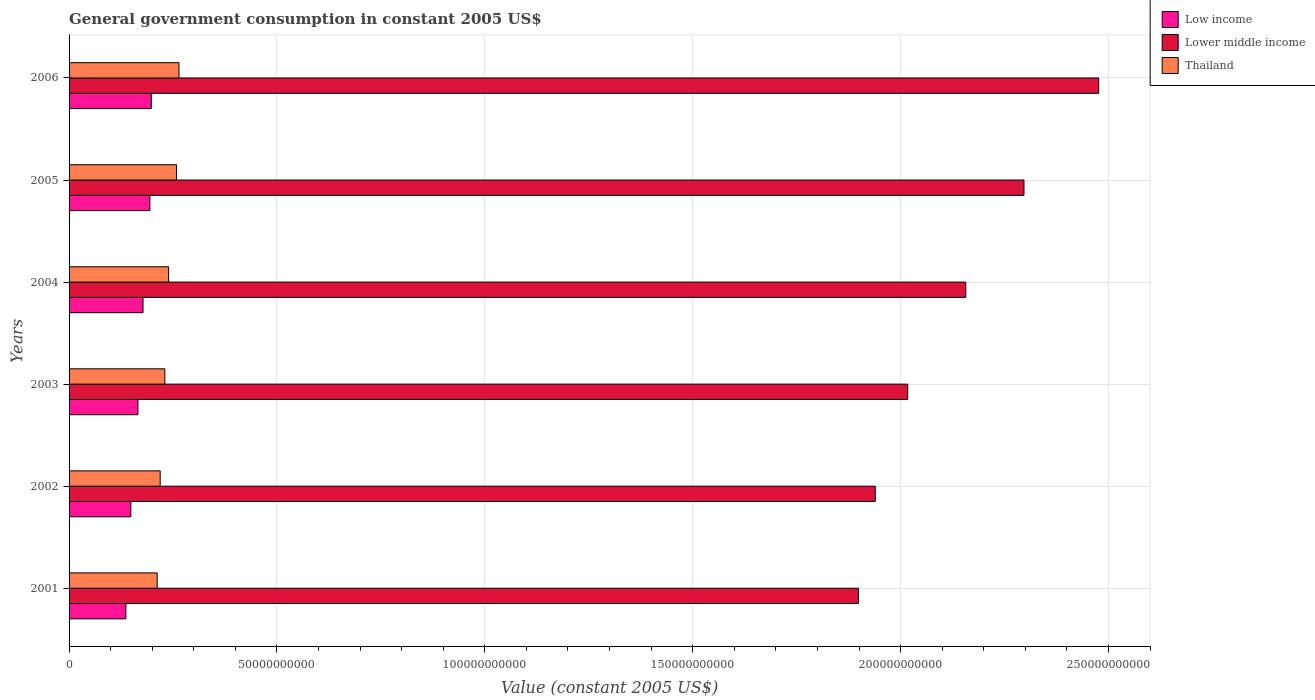How many different coloured bars are there?
Provide a succinct answer. 3. How many bars are there on the 2nd tick from the top?
Provide a succinct answer. 3. In how many cases, is the number of bars for a given year not equal to the number of legend labels?
Make the answer very short. 0. What is the government conusmption in Lower middle income in 2005?
Your answer should be very brief. 2.30e+11. Across all years, what is the maximum government conusmption in Low income?
Give a very brief answer. 1.98e+1. Across all years, what is the minimum government conusmption in Thailand?
Make the answer very short. 2.12e+1. In which year was the government conusmption in Lower middle income maximum?
Provide a short and direct response. 2006. What is the total government conusmption in Lower middle income in the graph?
Give a very brief answer. 1.28e+12. What is the difference between the government conusmption in Thailand in 2001 and that in 2006?
Make the answer very short. -5.24e+09. What is the difference between the government conusmption in Thailand in 2005 and the government conusmption in Low income in 2003?
Your answer should be very brief. 9.29e+09. What is the average government conusmption in Lower middle income per year?
Offer a very short reply. 2.13e+11. In the year 2003, what is the difference between the government conusmption in Lower middle income and government conusmption in Low income?
Ensure brevity in your answer.  1.85e+11. In how many years, is the government conusmption in Thailand greater than 30000000000 US$?
Your response must be concise. 0. What is the ratio of the government conusmption in Lower middle income in 2004 to that in 2005?
Ensure brevity in your answer.  0.94. Is the government conusmption in Thailand in 2001 less than that in 2002?
Your answer should be compact. Yes. What is the difference between the highest and the second highest government conusmption in Lower middle income?
Offer a very short reply. 1.80e+1. What is the difference between the highest and the lowest government conusmption in Lower middle income?
Provide a succinct answer. 5.78e+1. What does the 2nd bar from the bottom in 2003 represents?
Offer a very short reply. Lower middle income. Is it the case that in every year, the sum of the government conusmption in Lower middle income and government conusmption in Low income is greater than the government conusmption in Thailand?
Your answer should be very brief. Yes. How many bars are there?
Keep it short and to the point. 18. Are all the bars in the graph horizontal?
Ensure brevity in your answer.  Yes. How many years are there in the graph?
Your response must be concise. 6. Are the values on the major ticks of X-axis written in scientific E-notation?
Offer a terse response. No. Does the graph contain any zero values?
Your answer should be compact. No. Does the graph contain grids?
Make the answer very short. Yes. Where does the legend appear in the graph?
Provide a short and direct response. Top right. How many legend labels are there?
Keep it short and to the point. 3. What is the title of the graph?
Offer a very short reply. General government consumption in constant 2005 US$. What is the label or title of the X-axis?
Provide a succinct answer. Value (constant 2005 US$). What is the Value (constant 2005 US$) of Low income in 2001?
Your answer should be compact. 1.37e+1. What is the Value (constant 2005 US$) in Lower middle income in 2001?
Give a very brief answer. 1.90e+11. What is the Value (constant 2005 US$) in Thailand in 2001?
Your answer should be compact. 2.12e+1. What is the Value (constant 2005 US$) in Low income in 2002?
Provide a succinct answer. 1.49e+1. What is the Value (constant 2005 US$) of Lower middle income in 2002?
Your answer should be compact. 1.94e+11. What is the Value (constant 2005 US$) in Thailand in 2002?
Offer a terse response. 2.19e+1. What is the Value (constant 2005 US$) in Low income in 2003?
Ensure brevity in your answer.  1.66e+1. What is the Value (constant 2005 US$) of Lower middle income in 2003?
Provide a succinct answer. 2.02e+11. What is the Value (constant 2005 US$) of Thailand in 2003?
Keep it short and to the point. 2.30e+1. What is the Value (constant 2005 US$) in Low income in 2004?
Offer a terse response. 1.78e+1. What is the Value (constant 2005 US$) of Lower middle income in 2004?
Make the answer very short. 2.16e+11. What is the Value (constant 2005 US$) in Thailand in 2004?
Provide a short and direct response. 2.39e+1. What is the Value (constant 2005 US$) of Low income in 2005?
Your answer should be compact. 1.94e+1. What is the Value (constant 2005 US$) in Lower middle income in 2005?
Make the answer very short. 2.30e+11. What is the Value (constant 2005 US$) of Thailand in 2005?
Provide a short and direct response. 2.58e+1. What is the Value (constant 2005 US$) of Low income in 2006?
Your answer should be compact. 1.98e+1. What is the Value (constant 2005 US$) of Lower middle income in 2006?
Provide a succinct answer. 2.48e+11. What is the Value (constant 2005 US$) in Thailand in 2006?
Your response must be concise. 2.64e+1. Across all years, what is the maximum Value (constant 2005 US$) of Low income?
Provide a short and direct response. 1.98e+1. Across all years, what is the maximum Value (constant 2005 US$) in Lower middle income?
Give a very brief answer. 2.48e+11. Across all years, what is the maximum Value (constant 2005 US$) of Thailand?
Provide a succinct answer. 2.64e+1. Across all years, what is the minimum Value (constant 2005 US$) of Low income?
Offer a very short reply. 1.37e+1. Across all years, what is the minimum Value (constant 2005 US$) in Lower middle income?
Provide a succinct answer. 1.90e+11. Across all years, what is the minimum Value (constant 2005 US$) in Thailand?
Give a very brief answer. 2.12e+1. What is the total Value (constant 2005 US$) of Low income in the graph?
Your answer should be very brief. 1.02e+11. What is the total Value (constant 2005 US$) of Lower middle income in the graph?
Your answer should be compact. 1.28e+12. What is the total Value (constant 2005 US$) of Thailand in the graph?
Give a very brief answer. 1.42e+11. What is the difference between the Value (constant 2005 US$) of Low income in 2001 and that in 2002?
Offer a very short reply. -1.19e+09. What is the difference between the Value (constant 2005 US$) in Lower middle income in 2001 and that in 2002?
Your response must be concise. -4.05e+09. What is the difference between the Value (constant 2005 US$) of Thailand in 2001 and that in 2002?
Your response must be concise. -7.23e+08. What is the difference between the Value (constant 2005 US$) of Low income in 2001 and that in 2003?
Give a very brief answer. -2.90e+09. What is the difference between the Value (constant 2005 US$) of Lower middle income in 2001 and that in 2003?
Your answer should be compact. -1.19e+1. What is the difference between the Value (constant 2005 US$) in Thailand in 2001 and that in 2003?
Your answer should be compact. -1.85e+09. What is the difference between the Value (constant 2005 US$) in Low income in 2001 and that in 2004?
Provide a short and direct response. -4.13e+09. What is the difference between the Value (constant 2005 US$) in Lower middle income in 2001 and that in 2004?
Provide a succinct answer. -2.58e+1. What is the difference between the Value (constant 2005 US$) of Thailand in 2001 and that in 2004?
Keep it short and to the point. -2.74e+09. What is the difference between the Value (constant 2005 US$) in Low income in 2001 and that in 2005?
Give a very brief answer. -5.77e+09. What is the difference between the Value (constant 2005 US$) of Lower middle income in 2001 and that in 2005?
Ensure brevity in your answer.  -3.98e+1. What is the difference between the Value (constant 2005 US$) in Thailand in 2001 and that in 2005?
Give a very brief answer. -4.66e+09. What is the difference between the Value (constant 2005 US$) of Low income in 2001 and that in 2006?
Your answer should be compact. -6.11e+09. What is the difference between the Value (constant 2005 US$) in Lower middle income in 2001 and that in 2006?
Offer a very short reply. -5.78e+1. What is the difference between the Value (constant 2005 US$) in Thailand in 2001 and that in 2006?
Provide a short and direct response. -5.24e+09. What is the difference between the Value (constant 2005 US$) of Low income in 2002 and that in 2003?
Ensure brevity in your answer.  -1.71e+09. What is the difference between the Value (constant 2005 US$) of Lower middle income in 2002 and that in 2003?
Provide a short and direct response. -7.81e+09. What is the difference between the Value (constant 2005 US$) of Thailand in 2002 and that in 2003?
Your response must be concise. -1.12e+09. What is the difference between the Value (constant 2005 US$) in Low income in 2002 and that in 2004?
Provide a succinct answer. -2.93e+09. What is the difference between the Value (constant 2005 US$) of Lower middle income in 2002 and that in 2004?
Keep it short and to the point. -2.18e+1. What is the difference between the Value (constant 2005 US$) in Thailand in 2002 and that in 2004?
Make the answer very short. -2.02e+09. What is the difference between the Value (constant 2005 US$) of Low income in 2002 and that in 2005?
Make the answer very short. -4.58e+09. What is the difference between the Value (constant 2005 US$) in Lower middle income in 2002 and that in 2005?
Give a very brief answer. -3.58e+1. What is the difference between the Value (constant 2005 US$) in Thailand in 2002 and that in 2005?
Provide a succinct answer. -3.93e+09. What is the difference between the Value (constant 2005 US$) of Low income in 2002 and that in 2006?
Make the answer very short. -4.92e+09. What is the difference between the Value (constant 2005 US$) in Lower middle income in 2002 and that in 2006?
Your response must be concise. -5.37e+1. What is the difference between the Value (constant 2005 US$) in Thailand in 2002 and that in 2006?
Offer a terse response. -4.52e+09. What is the difference between the Value (constant 2005 US$) in Low income in 2003 and that in 2004?
Provide a succinct answer. -1.22e+09. What is the difference between the Value (constant 2005 US$) of Lower middle income in 2003 and that in 2004?
Ensure brevity in your answer.  -1.40e+1. What is the difference between the Value (constant 2005 US$) in Thailand in 2003 and that in 2004?
Your response must be concise. -8.98e+08. What is the difference between the Value (constant 2005 US$) in Low income in 2003 and that in 2005?
Ensure brevity in your answer.  -2.87e+09. What is the difference between the Value (constant 2005 US$) in Lower middle income in 2003 and that in 2005?
Provide a short and direct response. -2.80e+1. What is the difference between the Value (constant 2005 US$) of Thailand in 2003 and that in 2005?
Your response must be concise. -2.81e+09. What is the difference between the Value (constant 2005 US$) of Low income in 2003 and that in 2006?
Make the answer very short. -3.21e+09. What is the difference between the Value (constant 2005 US$) of Lower middle income in 2003 and that in 2006?
Your answer should be very brief. -4.59e+1. What is the difference between the Value (constant 2005 US$) of Thailand in 2003 and that in 2006?
Offer a terse response. -3.40e+09. What is the difference between the Value (constant 2005 US$) in Low income in 2004 and that in 2005?
Provide a succinct answer. -1.65e+09. What is the difference between the Value (constant 2005 US$) in Lower middle income in 2004 and that in 2005?
Provide a short and direct response. -1.40e+1. What is the difference between the Value (constant 2005 US$) of Thailand in 2004 and that in 2005?
Make the answer very short. -1.91e+09. What is the difference between the Value (constant 2005 US$) in Low income in 2004 and that in 2006?
Keep it short and to the point. -1.99e+09. What is the difference between the Value (constant 2005 US$) of Lower middle income in 2004 and that in 2006?
Your answer should be compact. -3.20e+1. What is the difference between the Value (constant 2005 US$) in Thailand in 2004 and that in 2006?
Your answer should be very brief. -2.50e+09. What is the difference between the Value (constant 2005 US$) in Low income in 2005 and that in 2006?
Provide a short and direct response. -3.42e+08. What is the difference between the Value (constant 2005 US$) in Lower middle income in 2005 and that in 2006?
Keep it short and to the point. -1.80e+1. What is the difference between the Value (constant 2005 US$) in Thailand in 2005 and that in 2006?
Offer a very short reply. -5.85e+08. What is the difference between the Value (constant 2005 US$) in Low income in 2001 and the Value (constant 2005 US$) in Lower middle income in 2002?
Your response must be concise. -1.80e+11. What is the difference between the Value (constant 2005 US$) in Low income in 2001 and the Value (constant 2005 US$) in Thailand in 2002?
Provide a short and direct response. -8.25e+09. What is the difference between the Value (constant 2005 US$) of Lower middle income in 2001 and the Value (constant 2005 US$) of Thailand in 2002?
Your response must be concise. 1.68e+11. What is the difference between the Value (constant 2005 US$) of Low income in 2001 and the Value (constant 2005 US$) of Lower middle income in 2003?
Give a very brief answer. -1.88e+11. What is the difference between the Value (constant 2005 US$) of Low income in 2001 and the Value (constant 2005 US$) of Thailand in 2003?
Ensure brevity in your answer.  -9.38e+09. What is the difference between the Value (constant 2005 US$) in Lower middle income in 2001 and the Value (constant 2005 US$) in Thailand in 2003?
Your answer should be very brief. 1.67e+11. What is the difference between the Value (constant 2005 US$) of Low income in 2001 and the Value (constant 2005 US$) of Lower middle income in 2004?
Provide a succinct answer. -2.02e+11. What is the difference between the Value (constant 2005 US$) in Low income in 2001 and the Value (constant 2005 US$) in Thailand in 2004?
Your answer should be very brief. -1.03e+1. What is the difference between the Value (constant 2005 US$) in Lower middle income in 2001 and the Value (constant 2005 US$) in Thailand in 2004?
Your response must be concise. 1.66e+11. What is the difference between the Value (constant 2005 US$) in Low income in 2001 and the Value (constant 2005 US$) in Lower middle income in 2005?
Offer a very short reply. -2.16e+11. What is the difference between the Value (constant 2005 US$) of Low income in 2001 and the Value (constant 2005 US$) of Thailand in 2005?
Ensure brevity in your answer.  -1.22e+1. What is the difference between the Value (constant 2005 US$) in Lower middle income in 2001 and the Value (constant 2005 US$) in Thailand in 2005?
Your answer should be very brief. 1.64e+11. What is the difference between the Value (constant 2005 US$) of Low income in 2001 and the Value (constant 2005 US$) of Lower middle income in 2006?
Ensure brevity in your answer.  -2.34e+11. What is the difference between the Value (constant 2005 US$) in Low income in 2001 and the Value (constant 2005 US$) in Thailand in 2006?
Make the answer very short. -1.28e+1. What is the difference between the Value (constant 2005 US$) in Lower middle income in 2001 and the Value (constant 2005 US$) in Thailand in 2006?
Provide a succinct answer. 1.63e+11. What is the difference between the Value (constant 2005 US$) of Low income in 2002 and the Value (constant 2005 US$) of Lower middle income in 2003?
Keep it short and to the point. -1.87e+11. What is the difference between the Value (constant 2005 US$) of Low income in 2002 and the Value (constant 2005 US$) of Thailand in 2003?
Make the answer very short. -8.18e+09. What is the difference between the Value (constant 2005 US$) in Lower middle income in 2002 and the Value (constant 2005 US$) in Thailand in 2003?
Make the answer very short. 1.71e+11. What is the difference between the Value (constant 2005 US$) in Low income in 2002 and the Value (constant 2005 US$) in Lower middle income in 2004?
Give a very brief answer. -2.01e+11. What is the difference between the Value (constant 2005 US$) of Low income in 2002 and the Value (constant 2005 US$) of Thailand in 2004?
Offer a very short reply. -9.08e+09. What is the difference between the Value (constant 2005 US$) of Lower middle income in 2002 and the Value (constant 2005 US$) of Thailand in 2004?
Give a very brief answer. 1.70e+11. What is the difference between the Value (constant 2005 US$) of Low income in 2002 and the Value (constant 2005 US$) of Lower middle income in 2005?
Your answer should be compact. -2.15e+11. What is the difference between the Value (constant 2005 US$) in Low income in 2002 and the Value (constant 2005 US$) in Thailand in 2005?
Your answer should be very brief. -1.10e+1. What is the difference between the Value (constant 2005 US$) of Lower middle income in 2002 and the Value (constant 2005 US$) of Thailand in 2005?
Your answer should be very brief. 1.68e+11. What is the difference between the Value (constant 2005 US$) of Low income in 2002 and the Value (constant 2005 US$) of Lower middle income in 2006?
Provide a short and direct response. -2.33e+11. What is the difference between the Value (constant 2005 US$) in Low income in 2002 and the Value (constant 2005 US$) in Thailand in 2006?
Your response must be concise. -1.16e+1. What is the difference between the Value (constant 2005 US$) in Lower middle income in 2002 and the Value (constant 2005 US$) in Thailand in 2006?
Your answer should be very brief. 1.67e+11. What is the difference between the Value (constant 2005 US$) of Low income in 2003 and the Value (constant 2005 US$) of Lower middle income in 2004?
Offer a terse response. -1.99e+11. What is the difference between the Value (constant 2005 US$) of Low income in 2003 and the Value (constant 2005 US$) of Thailand in 2004?
Ensure brevity in your answer.  -7.37e+09. What is the difference between the Value (constant 2005 US$) of Lower middle income in 2003 and the Value (constant 2005 US$) of Thailand in 2004?
Offer a very short reply. 1.78e+11. What is the difference between the Value (constant 2005 US$) of Low income in 2003 and the Value (constant 2005 US$) of Lower middle income in 2005?
Make the answer very short. -2.13e+11. What is the difference between the Value (constant 2005 US$) of Low income in 2003 and the Value (constant 2005 US$) of Thailand in 2005?
Keep it short and to the point. -9.29e+09. What is the difference between the Value (constant 2005 US$) in Lower middle income in 2003 and the Value (constant 2005 US$) in Thailand in 2005?
Offer a terse response. 1.76e+11. What is the difference between the Value (constant 2005 US$) of Low income in 2003 and the Value (constant 2005 US$) of Lower middle income in 2006?
Provide a succinct answer. -2.31e+11. What is the difference between the Value (constant 2005 US$) in Low income in 2003 and the Value (constant 2005 US$) in Thailand in 2006?
Provide a succinct answer. -9.87e+09. What is the difference between the Value (constant 2005 US$) of Lower middle income in 2003 and the Value (constant 2005 US$) of Thailand in 2006?
Offer a very short reply. 1.75e+11. What is the difference between the Value (constant 2005 US$) in Low income in 2004 and the Value (constant 2005 US$) in Lower middle income in 2005?
Make the answer very short. -2.12e+11. What is the difference between the Value (constant 2005 US$) in Low income in 2004 and the Value (constant 2005 US$) in Thailand in 2005?
Offer a very short reply. -8.06e+09. What is the difference between the Value (constant 2005 US$) in Lower middle income in 2004 and the Value (constant 2005 US$) in Thailand in 2005?
Offer a very short reply. 1.90e+11. What is the difference between the Value (constant 2005 US$) of Low income in 2004 and the Value (constant 2005 US$) of Lower middle income in 2006?
Provide a succinct answer. -2.30e+11. What is the difference between the Value (constant 2005 US$) of Low income in 2004 and the Value (constant 2005 US$) of Thailand in 2006?
Your response must be concise. -8.65e+09. What is the difference between the Value (constant 2005 US$) in Lower middle income in 2004 and the Value (constant 2005 US$) in Thailand in 2006?
Your response must be concise. 1.89e+11. What is the difference between the Value (constant 2005 US$) of Low income in 2005 and the Value (constant 2005 US$) of Lower middle income in 2006?
Keep it short and to the point. -2.28e+11. What is the difference between the Value (constant 2005 US$) in Low income in 2005 and the Value (constant 2005 US$) in Thailand in 2006?
Your answer should be compact. -7.00e+09. What is the difference between the Value (constant 2005 US$) in Lower middle income in 2005 and the Value (constant 2005 US$) in Thailand in 2006?
Give a very brief answer. 2.03e+11. What is the average Value (constant 2005 US$) in Low income per year?
Ensure brevity in your answer.  1.70e+1. What is the average Value (constant 2005 US$) in Lower middle income per year?
Provide a short and direct response. 2.13e+11. What is the average Value (constant 2005 US$) in Thailand per year?
Your response must be concise. 2.37e+1. In the year 2001, what is the difference between the Value (constant 2005 US$) of Low income and Value (constant 2005 US$) of Lower middle income?
Ensure brevity in your answer.  -1.76e+11. In the year 2001, what is the difference between the Value (constant 2005 US$) in Low income and Value (constant 2005 US$) in Thailand?
Your response must be concise. -7.53e+09. In the year 2001, what is the difference between the Value (constant 2005 US$) of Lower middle income and Value (constant 2005 US$) of Thailand?
Your answer should be very brief. 1.69e+11. In the year 2002, what is the difference between the Value (constant 2005 US$) in Low income and Value (constant 2005 US$) in Lower middle income?
Offer a very short reply. -1.79e+11. In the year 2002, what is the difference between the Value (constant 2005 US$) of Low income and Value (constant 2005 US$) of Thailand?
Offer a terse response. -7.06e+09. In the year 2002, what is the difference between the Value (constant 2005 US$) of Lower middle income and Value (constant 2005 US$) of Thailand?
Provide a short and direct response. 1.72e+11. In the year 2003, what is the difference between the Value (constant 2005 US$) in Low income and Value (constant 2005 US$) in Lower middle income?
Make the answer very short. -1.85e+11. In the year 2003, what is the difference between the Value (constant 2005 US$) of Low income and Value (constant 2005 US$) of Thailand?
Give a very brief answer. -6.47e+09. In the year 2003, what is the difference between the Value (constant 2005 US$) of Lower middle income and Value (constant 2005 US$) of Thailand?
Offer a very short reply. 1.79e+11. In the year 2004, what is the difference between the Value (constant 2005 US$) of Low income and Value (constant 2005 US$) of Lower middle income?
Your answer should be very brief. -1.98e+11. In the year 2004, what is the difference between the Value (constant 2005 US$) of Low income and Value (constant 2005 US$) of Thailand?
Offer a very short reply. -6.15e+09. In the year 2004, what is the difference between the Value (constant 2005 US$) in Lower middle income and Value (constant 2005 US$) in Thailand?
Your response must be concise. 1.92e+11. In the year 2005, what is the difference between the Value (constant 2005 US$) of Low income and Value (constant 2005 US$) of Lower middle income?
Make the answer very short. -2.10e+11. In the year 2005, what is the difference between the Value (constant 2005 US$) of Low income and Value (constant 2005 US$) of Thailand?
Keep it short and to the point. -6.42e+09. In the year 2005, what is the difference between the Value (constant 2005 US$) in Lower middle income and Value (constant 2005 US$) in Thailand?
Your answer should be very brief. 2.04e+11. In the year 2006, what is the difference between the Value (constant 2005 US$) of Low income and Value (constant 2005 US$) of Lower middle income?
Provide a short and direct response. -2.28e+11. In the year 2006, what is the difference between the Value (constant 2005 US$) in Low income and Value (constant 2005 US$) in Thailand?
Ensure brevity in your answer.  -6.66e+09. In the year 2006, what is the difference between the Value (constant 2005 US$) in Lower middle income and Value (constant 2005 US$) in Thailand?
Ensure brevity in your answer.  2.21e+11. What is the ratio of the Value (constant 2005 US$) of Low income in 2001 to that in 2002?
Make the answer very short. 0.92. What is the ratio of the Value (constant 2005 US$) of Lower middle income in 2001 to that in 2002?
Offer a terse response. 0.98. What is the ratio of the Value (constant 2005 US$) in Thailand in 2001 to that in 2002?
Make the answer very short. 0.97. What is the ratio of the Value (constant 2005 US$) of Low income in 2001 to that in 2003?
Your answer should be compact. 0.82. What is the ratio of the Value (constant 2005 US$) of Lower middle income in 2001 to that in 2003?
Ensure brevity in your answer.  0.94. What is the ratio of the Value (constant 2005 US$) of Thailand in 2001 to that in 2003?
Give a very brief answer. 0.92. What is the ratio of the Value (constant 2005 US$) in Low income in 2001 to that in 2004?
Offer a terse response. 0.77. What is the ratio of the Value (constant 2005 US$) in Lower middle income in 2001 to that in 2004?
Your response must be concise. 0.88. What is the ratio of the Value (constant 2005 US$) in Thailand in 2001 to that in 2004?
Provide a succinct answer. 0.89. What is the ratio of the Value (constant 2005 US$) in Low income in 2001 to that in 2005?
Offer a very short reply. 0.7. What is the ratio of the Value (constant 2005 US$) in Lower middle income in 2001 to that in 2005?
Your response must be concise. 0.83. What is the ratio of the Value (constant 2005 US$) of Thailand in 2001 to that in 2005?
Your response must be concise. 0.82. What is the ratio of the Value (constant 2005 US$) of Low income in 2001 to that in 2006?
Provide a short and direct response. 0.69. What is the ratio of the Value (constant 2005 US$) of Lower middle income in 2001 to that in 2006?
Give a very brief answer. 0.77. What is the ratio of the Value (constant 2005 US$) of Thailand in 2001 to that in 2006?
Provide a succinct answer. 0.8. What is the ratio of the Value (constant 2005 US$) in Low income in 2002 to that in 2003?
Make the answer very short. 0.9. What is the ratio of the Value (constant 2005 US$) of Lower middle income in 2002 to that in 2003?
Provide a succinct answer. 0.96. What is the ratio of the Value (constant 2005 US$) in Thailand in 2002 to that in 2003?
Ensure brevity in your answer.  0.95. What is the ratio of the Value (constant 2005 US$) of Low income in 2002 to that in 2004?
Offer a very short reply. 0.84. What is the ratio of the Value (constant 2005 US$) of Lower middle income in 2002 to that in 2004?
Give a very brief answer. 0.9. What is the ratio of the Value (constant 2005 US$) in Thailand in 2002 to that in 2004?
Give a very brief answer. 0.92. What is the ratio of the Value (constant 2005 US$) in Low income in 2002 to that in 2005?
Offer a terse response. 0.76. What is the ratio of the Value (constant 2005 US$) of Lower middle income in 2002 to that in 2005?
Your response must be concise. 0.84. What is the ratio of the Value (constant 2005 US$) of Thailand in 2002 to that in 2005?
Make the answer very short. 0.85. What is the ratio of the Value (constant 2005 US$) of Low income in 2002 to that in 2006?
Make the answer very short. 0.75. What is the ratio of the Value (constant 2005 US$) of Lower middle income in 2002 to that in 2006?
Give a very brief answer. 0.78. What is the ratio of the Value (constant 2005 US$) of Thailand in 2002 to that in 2006?
Offer a very short reply. 0.83. What is the ratio of the Value (constant 2005 US$) of Low income in 2003 to that in 2004?
Provide a short and direct response. 0.93. What is the ratio of the Value (constant 2005 US$) of Lower middle income in 2003 to that in 2004?
Ensure brevity in your answer.  0.94. What is the ratio of the Value (constant 2005 US$) of Thailand in 2003 to that in 2004?
Your response must be concise. 0.96. What is the ratio of the Value (constant 2005 US$) in Low income in 2003 to that in 2005?
Keep it short and to the point. 0.85. What is the ratio of the Value (constant 2005 US$) in Lower middle income in 2003 to that in 2005?
Give a very brief answer. 0.88. What is the ratio of the Value (constant 2005 US$) in Thailand in 2003 to that in 2005?
Your answer should be very brief. 0.89. What is the ratio of the Value (constant 2005 US$) in Low income in 2003 to that in 2006?
Your answer should be compact. 0.84. What is the ratio of the Value (constant 2005 US$) in Lower middle income in 2003 to that in 2006?
Offer a terse response. 0.81. What is the ratio of the Value (constant 2005 US$) of Thailand in 2003 to that in 2006?
Give a very brief answer. 0.87. What is the ratio of the Value (constant 2005 US$) of Low income in 2004 to that in 2005?
Offer a terse response. 0.92. What is the ratio of the Value (constant 2005 US$) in Lower middle income in 2004 to that in 2005?
Offer a terse response. 0.94. What is the ratio of the Value (constant 2005 US$) of Thailand in 2004 to that in 2005?
Your response must be concise. 0.93. What is the ratio of the Value (constant 2005 US$) in Low income in 2004 to that in 2006?
Your answer should be compact. 0.9. What is the ratio of the Value (constant 2005 US$) in Lower middle income in 2004 to that in 2006?
Keep it short and to the point. 0.87. What is the ratio of the Value (constant 2005 US$) of Thailand in 2004 to that in 2006?
Your response must be concise. 0.91. What is the ratio of the Value (constant 2005 US$) of Low income in 2005 to that in 2006?
Make the answer very short. 0.98. What is the ratio of the Value (constant 2005 US$) in Lower middle income in 2005 to that in 2006?
Provide a short and direct response. 0.93. What is the ratio of the Value (constant 2005 US$) of Thailand in 2005 to that in 2006?
Offer a terse response. 0.98. What is the difference between the highest and the second highest Value (constant 2005 US$) of Low income?
Keep it short and to the point. 3.42e+08. What is the difference between the highest and the second highest Value (constant 2005 US$) of Lower middle income?
Your response must be concise. 1.80e+1. What is the difference between the highest and the second highest Value (constant 2005 US$) of Thailand?
Provide a succinct answer. 5.85e+08. What is the difference between the highest and the lowest Value (constant 2005 US$) of Low income?
Offer a very short reply. 6.11e+09. What is the difference between the highest and the lowest Value (constant 2005 US$) of Lower middle income?
Ensure brevity in your answer.  5.78e+1. What is the difference between the highest and the lowest Value (constant 2005 US$) in Thailand?
Offer a terse response. 5.24e+09. 